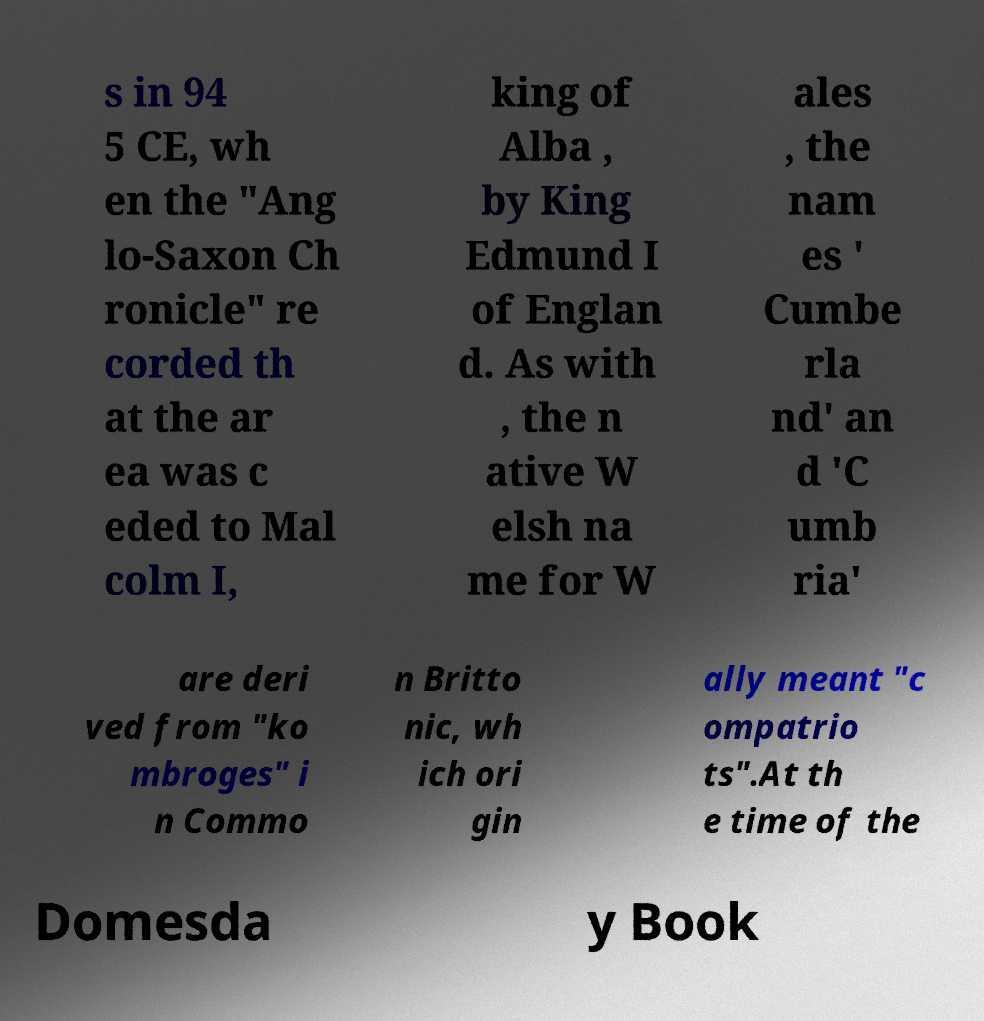For documentation purposes, I need the text within this image transcribed. Could you provide that? s in 94 5 CE, wh en the "Ang lo-Saxon Ch ronicle" re corded th at the ar ea was c eded to Mal colm I, king of Alba , by King Edmund I of Englan d. As with , the n ative W elsh na me for W ales , the nam es ' Cumbe rla nd' an d 'C umb ria' are deri ved from "ko mbroges" i n Commo n Britto nic, wh ich ori gin ally meant "c ompatrio ts".At th e time of the Domesda y Book 